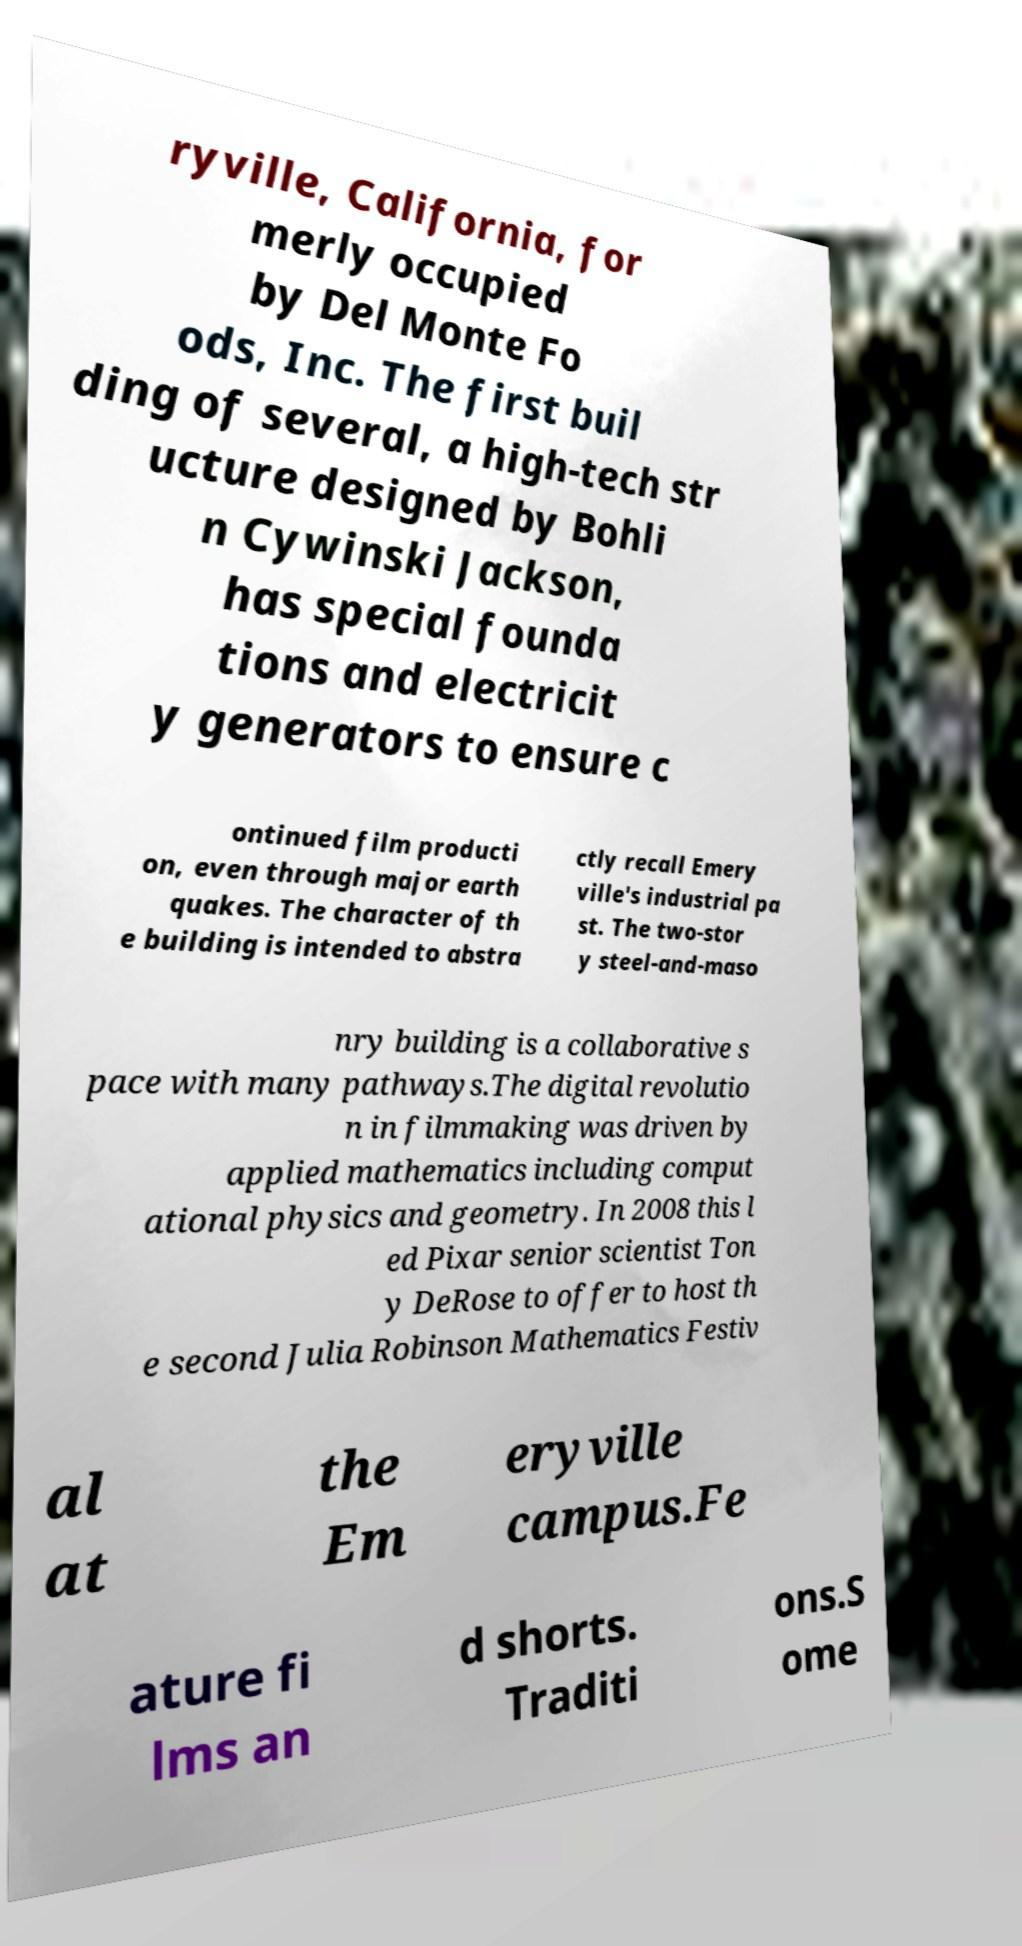Could you assist in decoding the text presented in this image and type it out clearly? ryville, California, for merly occupied by Del Monte Fo ods, Inc. The first buil ding of several, a high-tech str ucture designed by Bohli n Cywinski Jackson, has special founda tions and electricit y generators to ensure c ontinued film producti on, even through major earth quakes. The character of th e building is intended to abstra ctly recall Emery ville's industrial pa st. The two-stor y steel-and-maso nry building is a collaborative s pace with many pathways.The digital revolutio n in filmmaking was driven by applied mathematics including comput ational physics and geometry. In 2008 this l ed Pixar senior scientist Ton y DeRose to offer to host th e second Julia Robinson Mathematics Festiv al at the Em eryville campus.Fe ature fi lms an d shorts. Traditi ons.S ome 